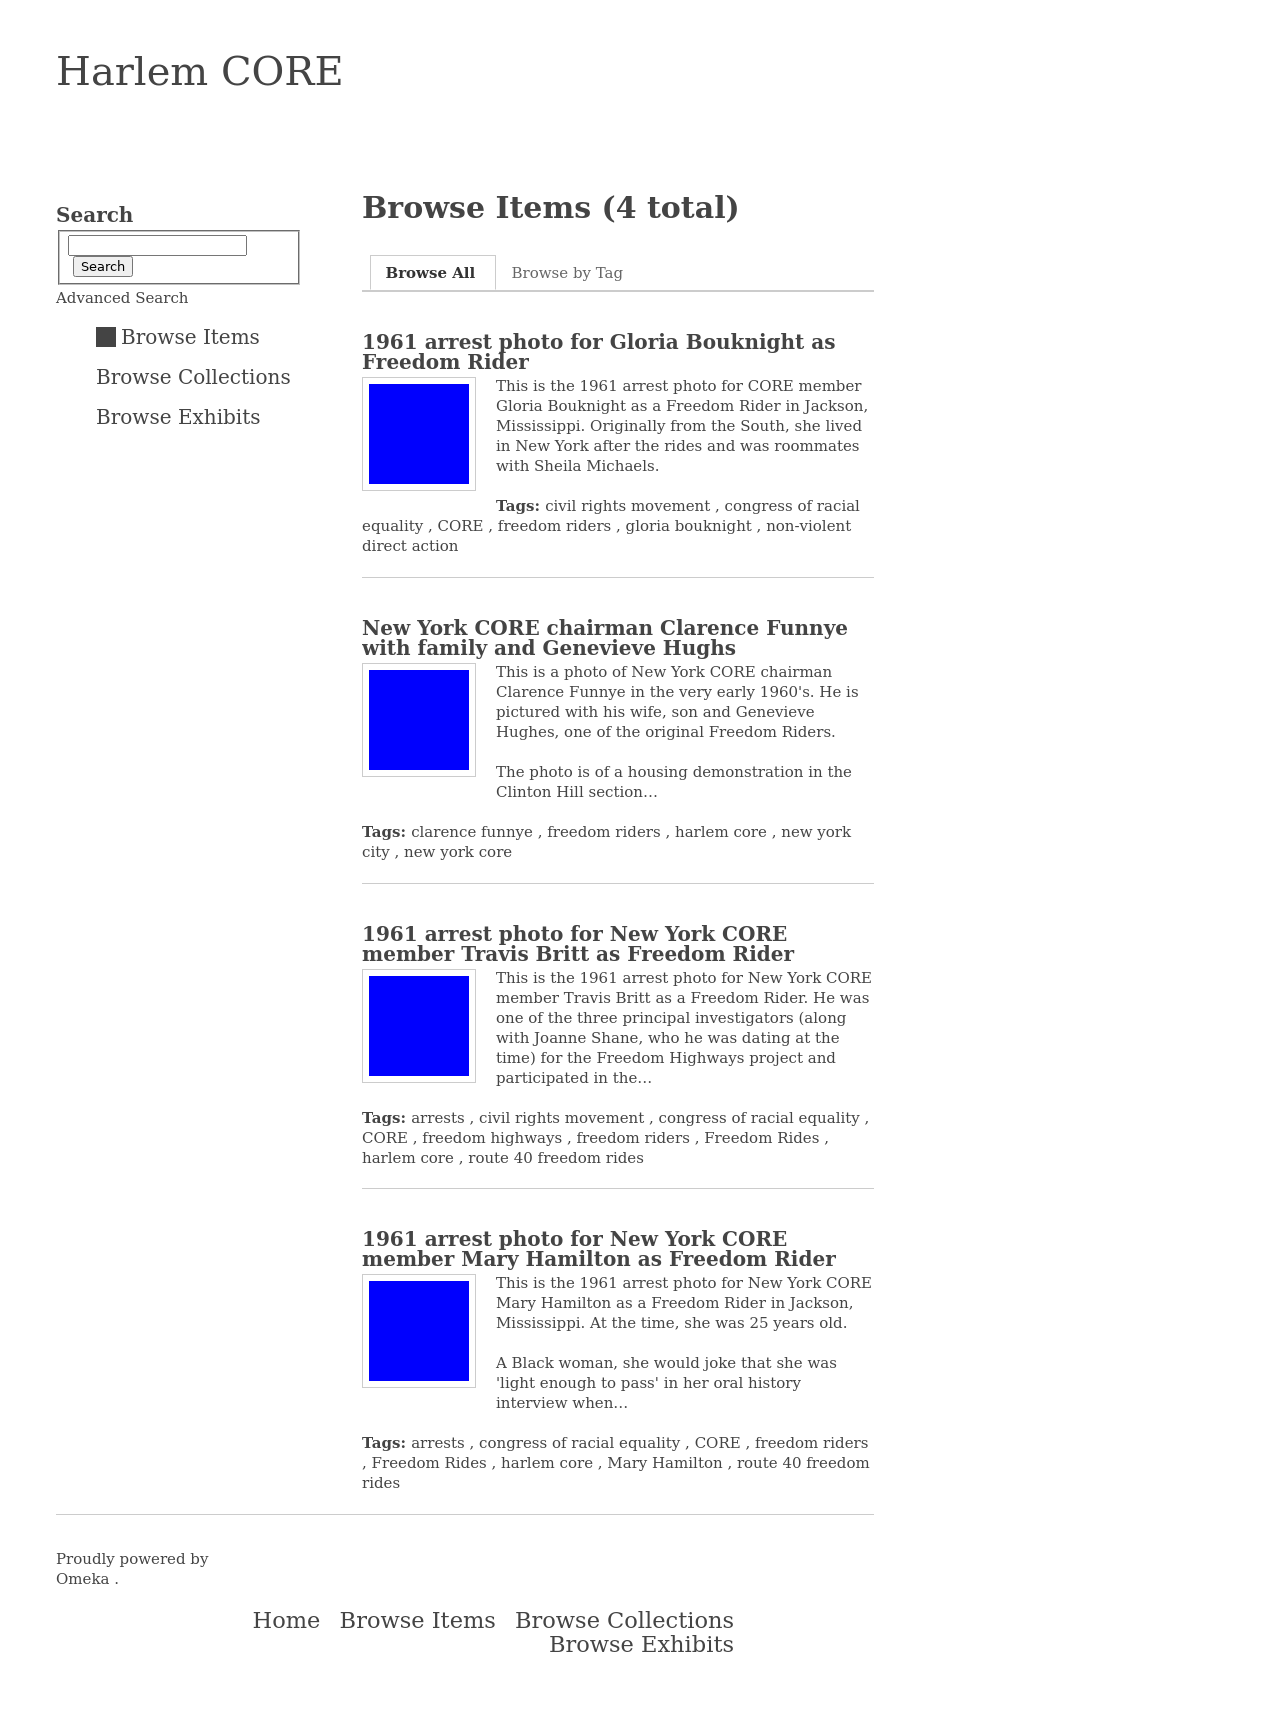How can I start building this website with HTML from the ground up? To start building a website similar to the one depicted in the image—an archive detailing the history of the Harlem CORE—you would begin by structuring your HTML to include sections such as a header, a navigation menu, main content area, and footer. For each historical item, you can create individual div elements with nested tags for images, descriptions, and tags. Remember to include 'alt' attributes for accessibility in your image tags and semantic elements like 'article' for each item. Additionally, consider using ARIA roles for enhanced accessibility and SEO. Your CSS styles should aim to recreate the clean and structured layout seen in the image. 